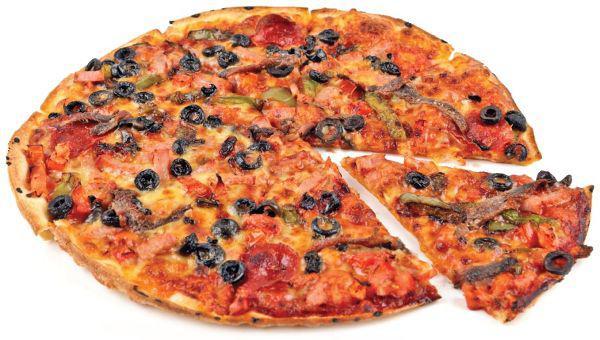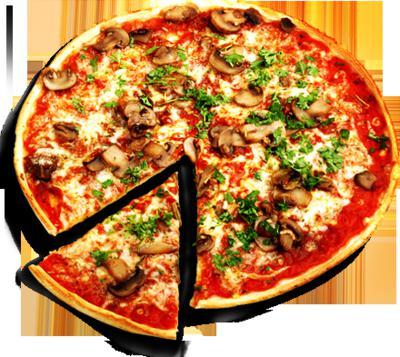The first image is the image on the left, the second image is the image on the right. Examine the images to the left and right. Is the description "Both pizzas have a drizzle of white sauce on top." accurate? Answer yes or no. No. The first image is the image on the left, the second image is the image on the right. For the images shown, is this caption "Each image shows a whole round pizza topped with a spiral of white cheese, and at least one pizza has a green chile pepper on top." true? Answer yes or no. No. 